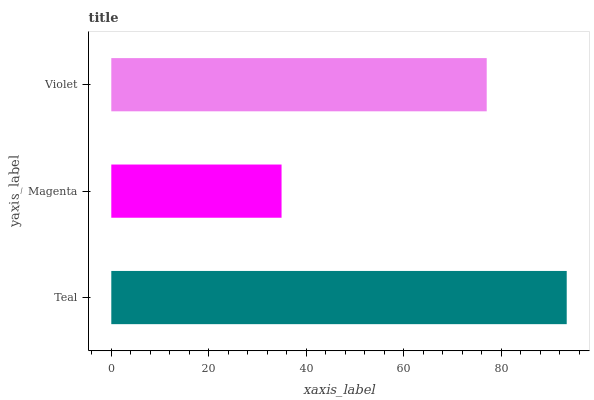Is Magenta the minimum?
Answer yes or no. Yes. Is Teal the maximum?
Answer yes or no. Yes. Is Violet the minimum?
Answer yes or no. No. Is Violet the maximum?
Answer yes or no. No. Is Violet greater than Magenta?
Answer yes or no. Yes. Is Magenta less than Violet?
Answer yes or no. Yes. Is Magenta greater than Violet?
Answer yes or no. No. Is Violet less than Magenta?
Answer yes or no. No. Is Violet the high median?
Answer yes or no. Yes. Is Violet the low median?
Answer yes or no. Yes. Is Teal the high median?
Answer yes or no. No. Is Teal the low median?
Answer yes or no. No. 